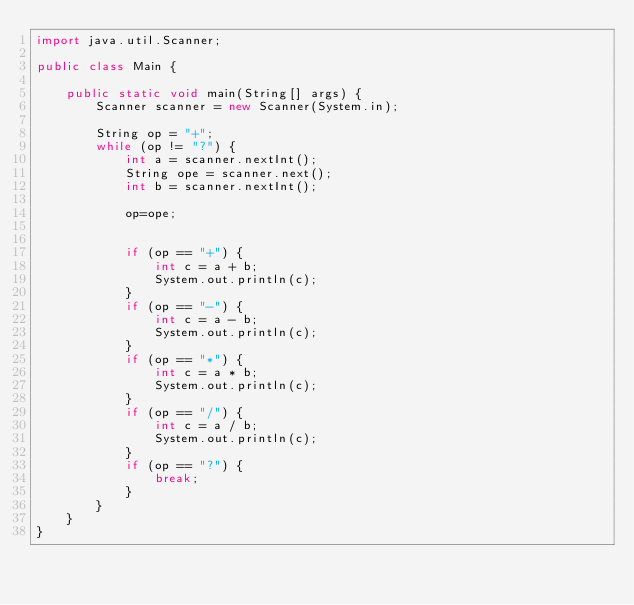Convert code to text. <code><loc_0><loc_0><loc_500><loc_500><_Java_>import java.util.Scanner;

public class Main {

    public static void main(String[] args) {
        Scanner scanner = new Scanner(System.in);

        String op = "+";
        while (op != "?") {
            int a = scanner.nextInt();
            String ope = scanner.next();
            int b = scanner.nextInt();
            
            op=ope;
            
            
            if (op == "+") {
                int c = a + b;
                System.out.println(c);
            }
            if (op == "-") {
                int c = a - b;
                System.out.println(c);
            }
            if (op == "*") {
                int c = a * b;
                System.out.println(c);
            }
            if (op == "/") {
                int c = a / b;
                System.out.println(c);
            }
            if (op == "?") {
                break;
            }
        }
    }
}</code> 